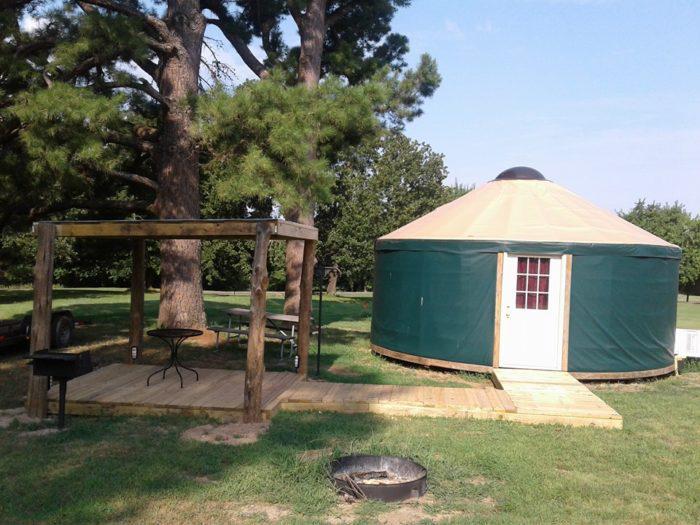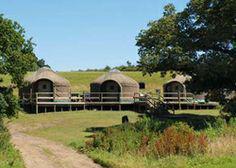The first image is the image on the left, the second image is the image on the right. For the images shown, is this caption "A yurt in one image features a white door with nine-pane window and a wooden walkway, but has no visible windows." true? Answer yes or no. Yes. The first image is the image on the left, the second image is the image on the right. Evaluate the accuracy of this statement regarding the images: "One image shows a yurt standing on a fresh-water shore, and the other image shows a yurt with decks extending from it and evergreens behind it.". Is it true? Answer yes or no. No. 